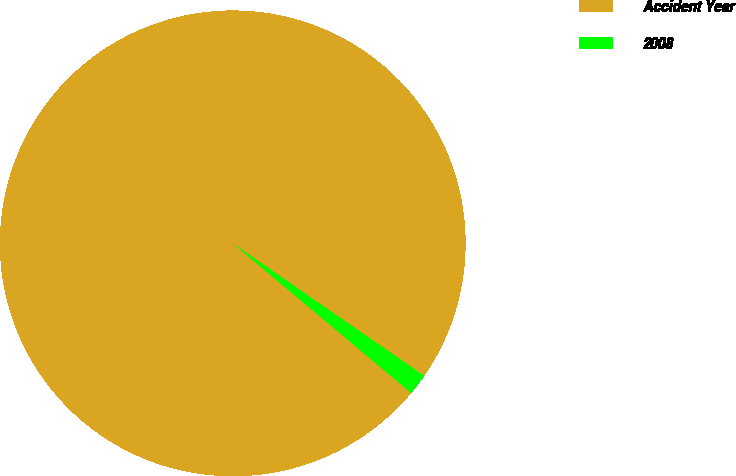Convert chart. <chart><loc_0><loc_0><loc_500><loc_500><pie_chart><fcel>Accident Year<fcel>2008<nl><fcel>98.53%<fcel>1.47%<nl></chart> 